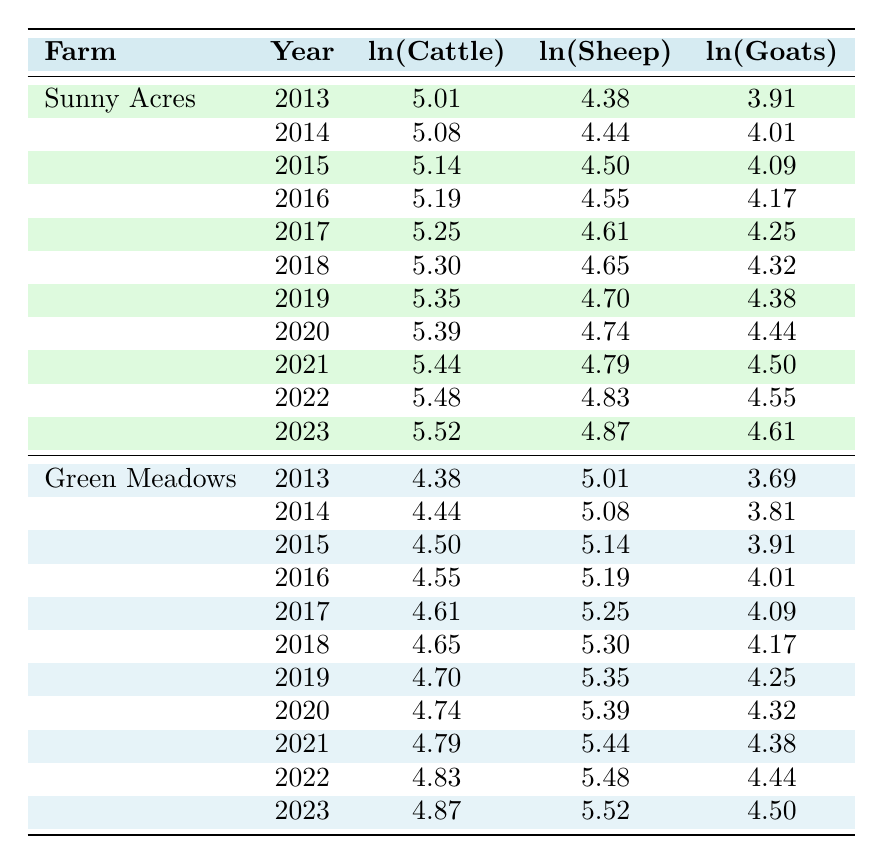What was the cattle population in Sunny Acres Farm in 2016? By looking at the table, I find the row for Sunny Acres Farm in the year 2016, where the cattle population is listed as 180.
Answer: 180 What is the natural logarithm of the goat population at Green Meadows Farm in 2021? For Green Meadows Farm in 2021, the goat population is shown as 80, and its natural logarithm value is 4.38.
Answer: 4.38 What is the total sheep population for Sunny Acres Farm from 2013 to 2023? To find the total sheep population for Sunny Acres Farm, I add the sheep populations from each year listed: 80 + 85 + 90 + 95 + 100 + 105 + 110 + 115 + 120 + 125 + 130 = 1,315.
Answer: 1315 Does the goat population at Green Meadows Farm increase every year? Upon reviewing the goat populations listed from 2013 to 2023, I see that they consistently increase each year: 40, 45, 50, 55, 60, 65, 70, 75, 80, 85, 90.
Answer: Yes What is the average natural logarithm of the sheep population at Sunny Acres Farm over the last decade? To find the average, I sum the natural logarithm values of the sheep population for each year (4.38 + 4.44 + 4.50 + 4.55 + 4.61 + 4.65 + 4.70 + 4.74 + 4.79 + 4.83 + 4.87 = 51.27) and divide by the number of years (11), which gives an average of approximately 4.66.
Answer: 4.66 What was the logarithmic values for cattle in Green Meadows Farm in 2019 and 2020? I can refer to the table: for 2019 the value is 4.70 and for 2020 it is 4.74.
Answer: 4.70 and 4.74 How many years did Sunny Acres Farm have a cattle population over 200? Reviewing the data from Sunny Acres Farm, the years with a cattle population over 200 are 2018, 2019, 2020, 2021, 2022, and 2023, making it 6 years.
Answer: 6 Is the increase in cattle population at Sunny Acres Farm consistent every year? I analyze the yearly data and find that the population increased by a constant 10 cattle each year, indicating a consistent increase.
Answer: Yes What is the difference in the natural logarithm values of goats between 2013 and 2023 at Green Meadows Farm? From the table, the ln(Goats) in 2013 is 3.69 and in 2023 is 4.50. The difference is 4.50 - 3.69 = 0.81.
Answer: 0.81 